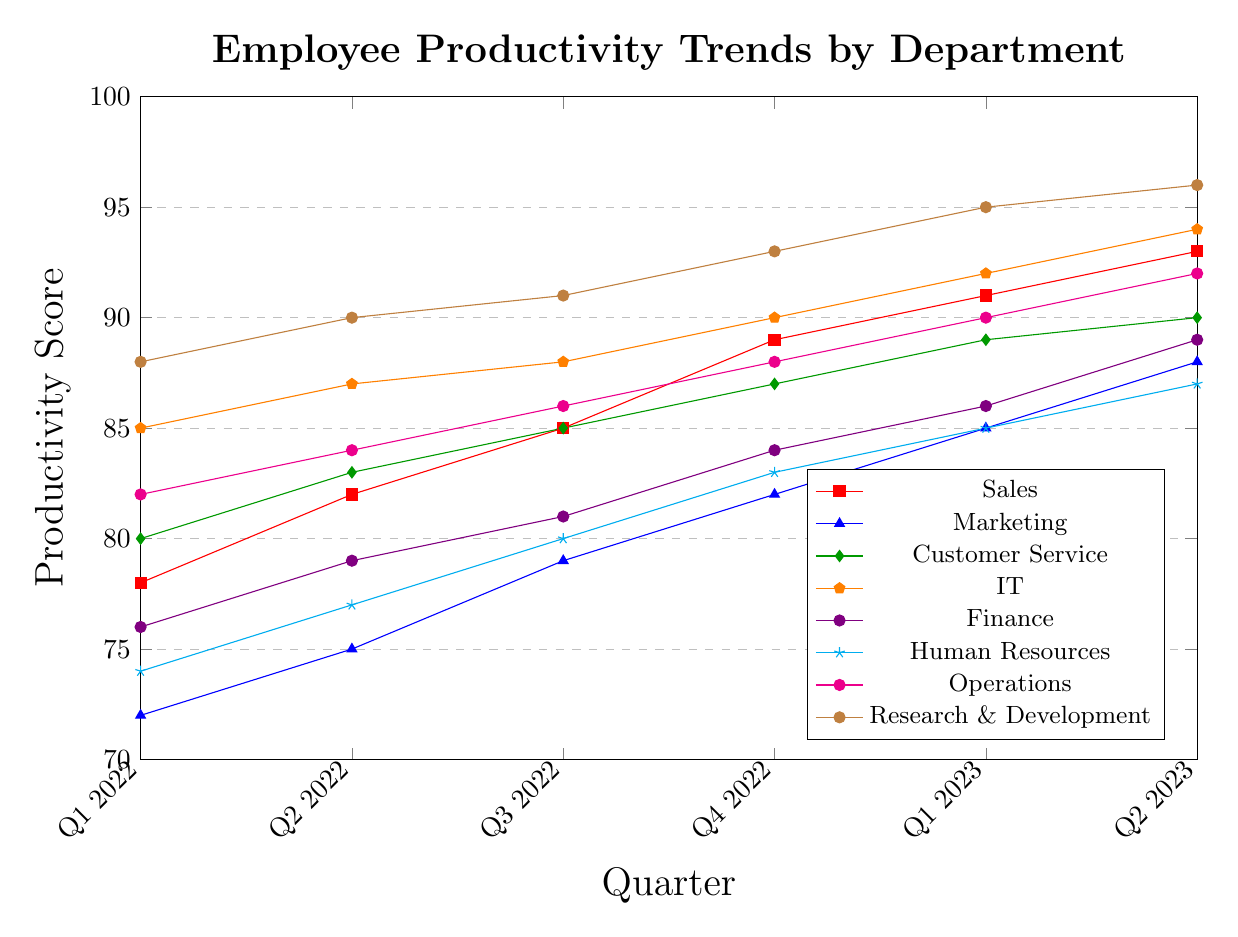Which department had the highest employee productivity score in Q2 2023? First, locate Q2 2023 on the x-axis and then identify the highest value on the y-axis within that quarter. Research & Development reached 96, which is the highest among all departments.
Answer: Research & Development What is the average productivity score for the Marketing department over the given time period? List the productivity scores for Marketing: 72, 75, 79, 82, 85, 88. Sum these values and divide by the number of data points: (72+75+79+82+85+88)/6 = 80.17.
Answer: 80.17 Which department showed the least improvement in productivity from Q1 2022 to Q2 2023? Calculate the difference between Q1 2022 and Q2 2023 for each department: Sales (15), Marketing (16), Customer Service (10), IT (9), Finance (13), Human Resources (13), Operations (10), Research & Development (8). The least improvement was by IT with an increase of 9.
Answer: IT In which quarter did the Customer Service department's productivity first surpass 85? Identify the points where Customer Service's productivity was more than 85: Q3 2022 (85), Q4 2022 (87), Q1 2023 (89), Q2 2023 (90). The first surpass was Q4 2022.
Answer: Q4 2022 Compare the trend of the Finance and Operations departments; which department had a higher productivity score in Q1 2023? Find the productivity scores for Q1 2023 for both departments: Finance (86) and Operations (90). Operations had a higher score.
Answer: Operations Calculate the difference in productivity scores between Q1 2022 and Q4 2022 for the Sales department. Locate the productivity scores for Q1 2022 (78) and Q4 2022 (89) for Sales. Subtract Q1 from Q4: 89 - 78 = 11.
Answer: 11 Which department had the most consistent rise in productivity over the given period? Identify the department with a steady increase by comparing scores across all quarters. Research & Development consistently increased without any plateau or drop: 88, 90, 91, 93, 95, 96.
Answer: Research & Development How many quarters did it take for the Human Resources department to reach a productivity score of 80 or more? Starting from Q1 2022, find the first instance where Human Resources scored 80 or more: Q3 2022. It took 3 quarters from Q1 2022 to Q3 2022.
Answer: 3 Which departments had identical productivity scores in Q4 2022? Compare the scores of all departments in Q4 2022. Customer Service and Operations both had a score of 88 in Q4 2022.
Answer: Customer Service and Operations 